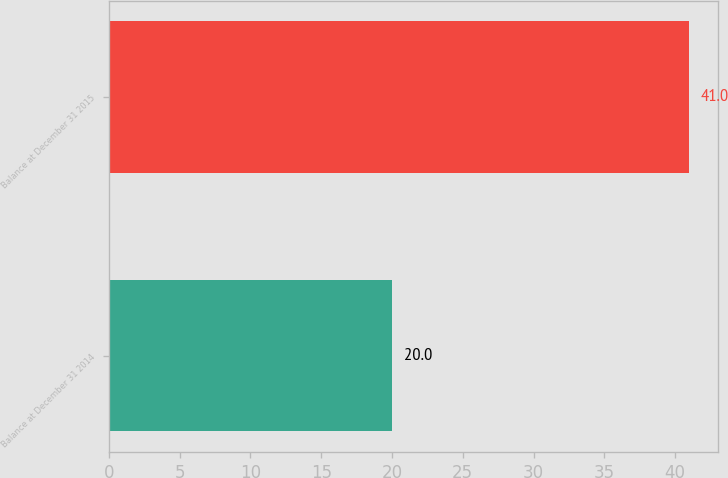Convert chart. <chart><loc_0><loc_0><loc_500><loc_500><bar_chart><fcel>Balance at December 31 2014<fcel>Balance at December 31 2015<nl><fcel>20<fcel>41<nl></chart> 